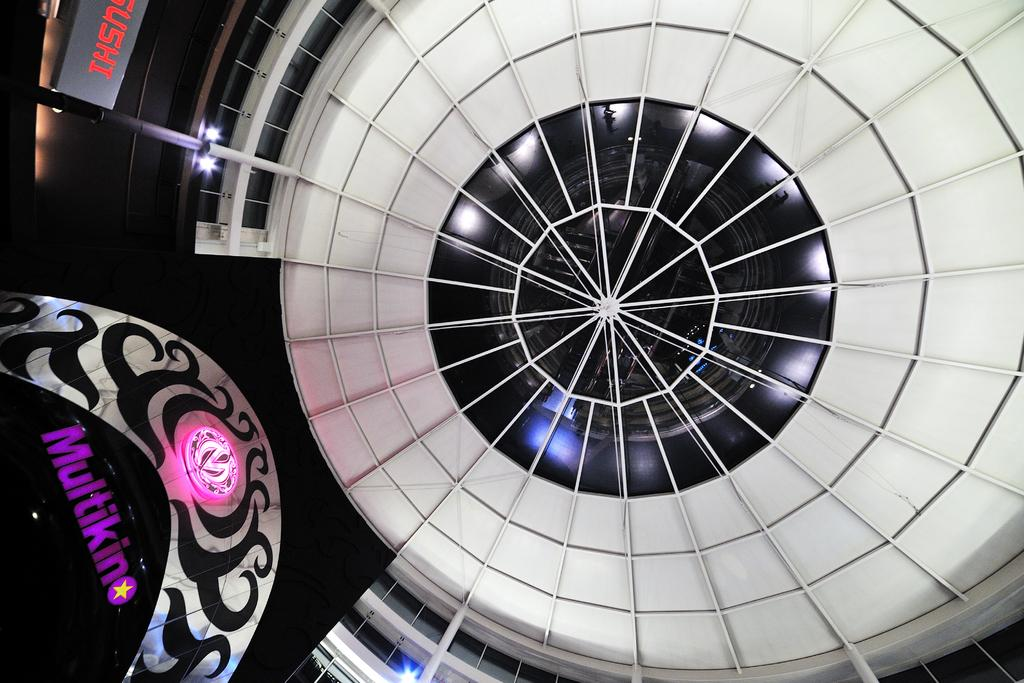What part of a building is visible in the image? The image shows the roof of a building. Is there any text present in the image? Yes, there is some text at the left side of the image. What type of spoon can be seen on the roof in the image? There is no spoon present in the image; it only shows the roof of a building and some text. 